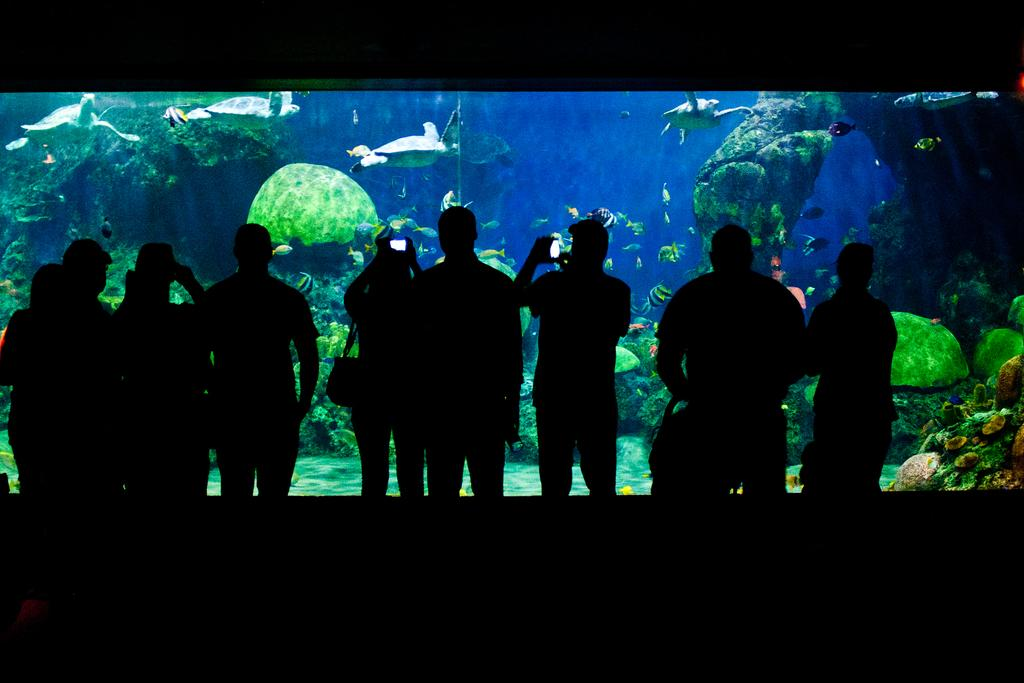What is happening in the image? There are persons standing in the image. What can be seen in the background of the image? There is an aquarium in the image. What types of animals are present in the aquarium? The aquarium contains turtles and fishes. What else can be found in the aquarium? The aquarium contains plants. What type of insurance policy is being discussed by the persons in the image? There is no indication in the image that the persons are discussing insurance policies. 